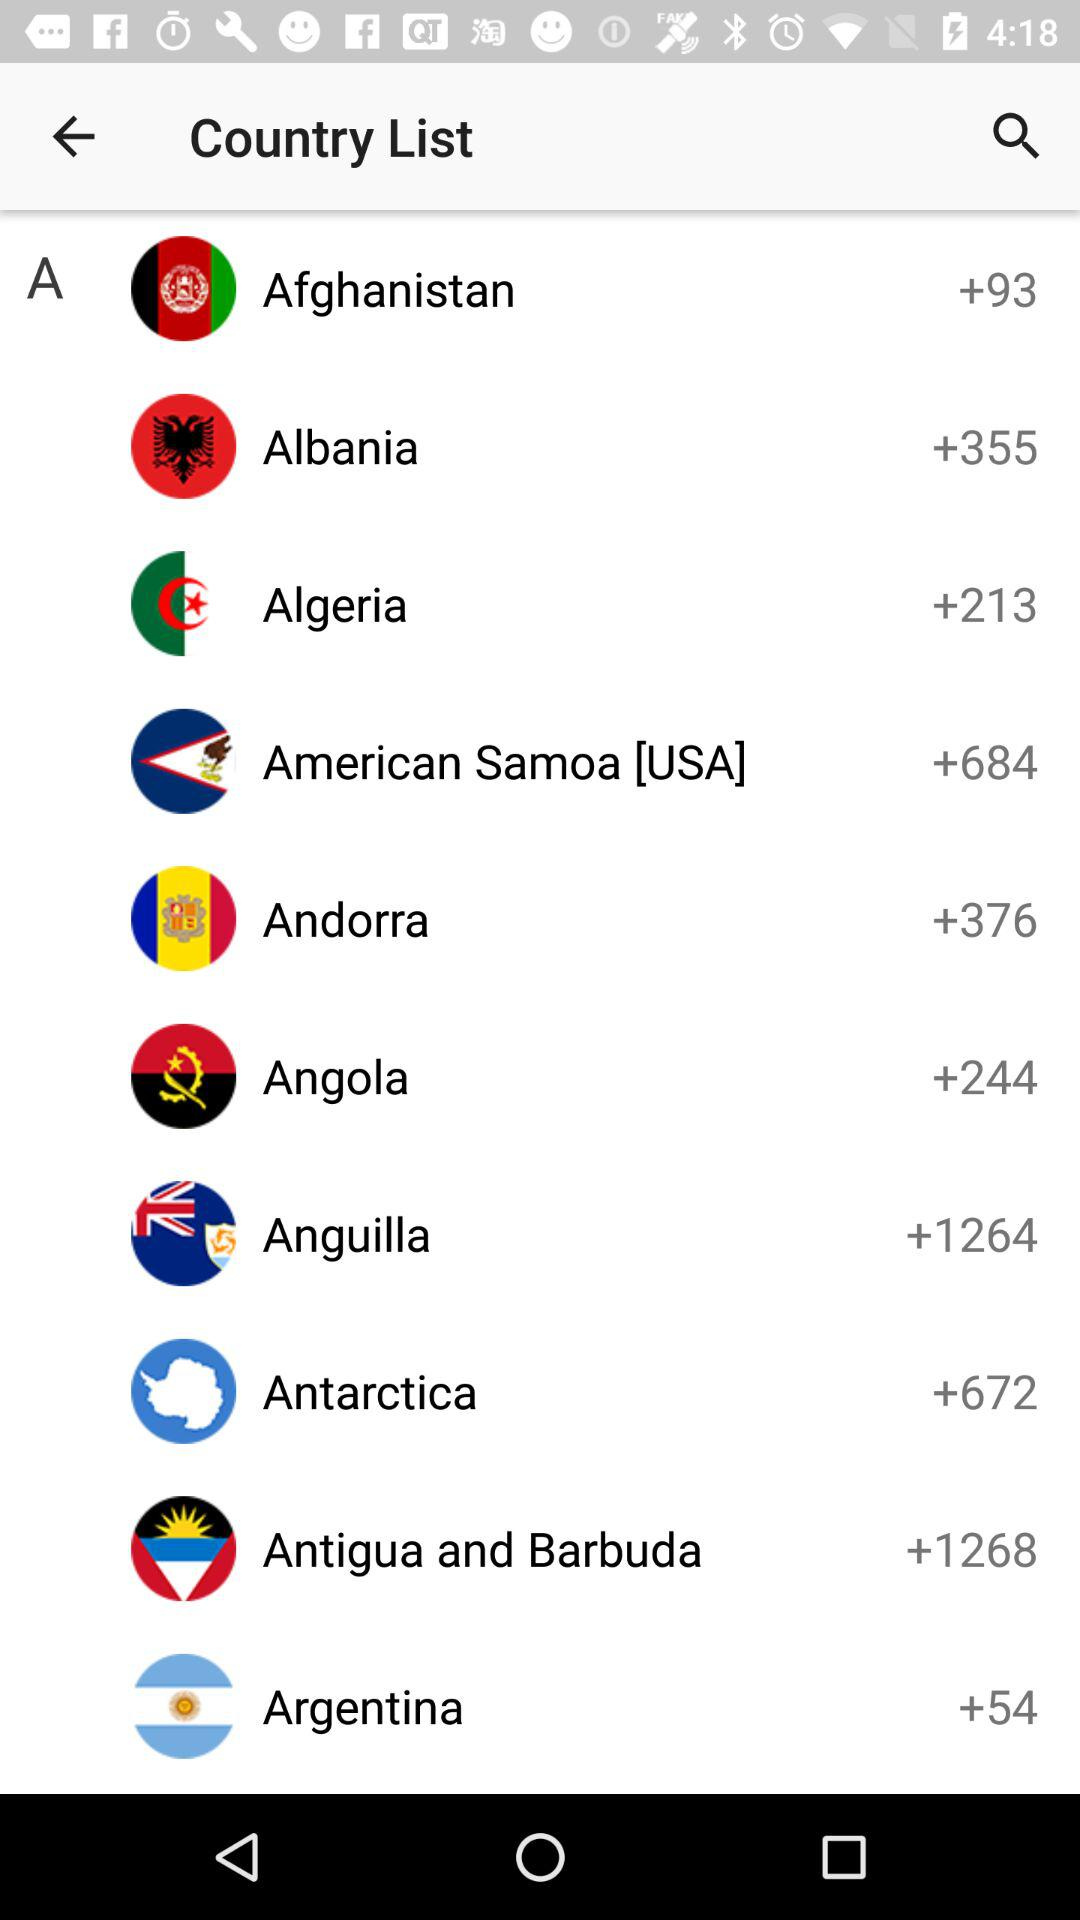What is the country code for Angola? The country code for Angola is +244. 